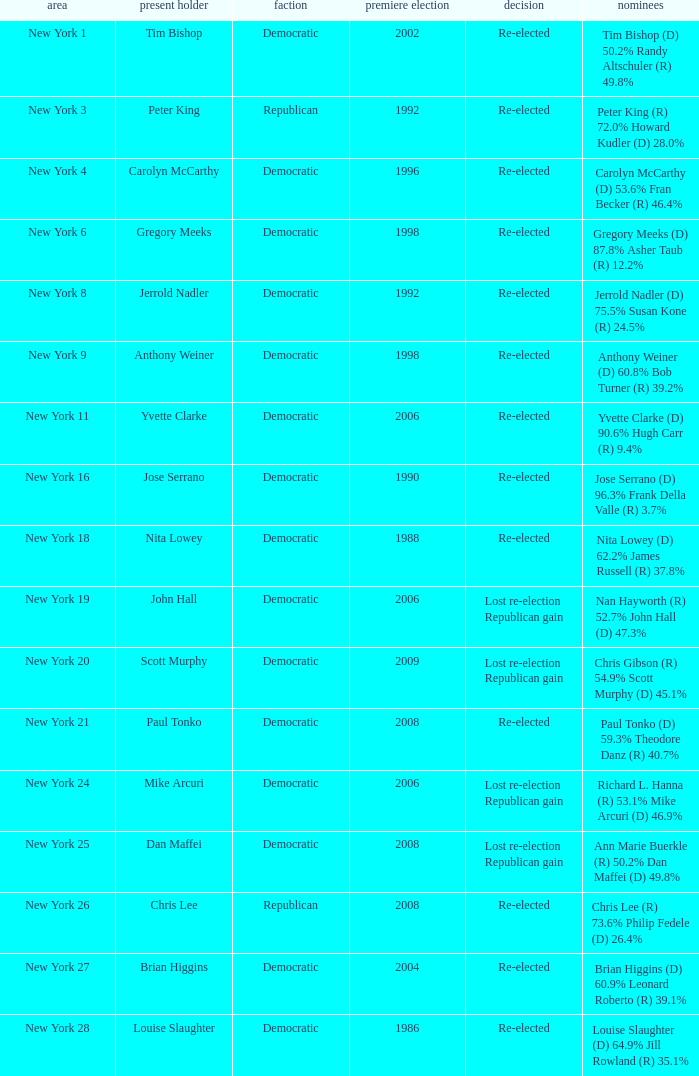Name the number of party for richard l. hanna (r) 53.1% mike arcuri (d) 46.9% 1.0. 